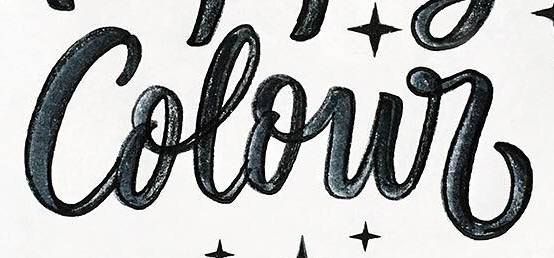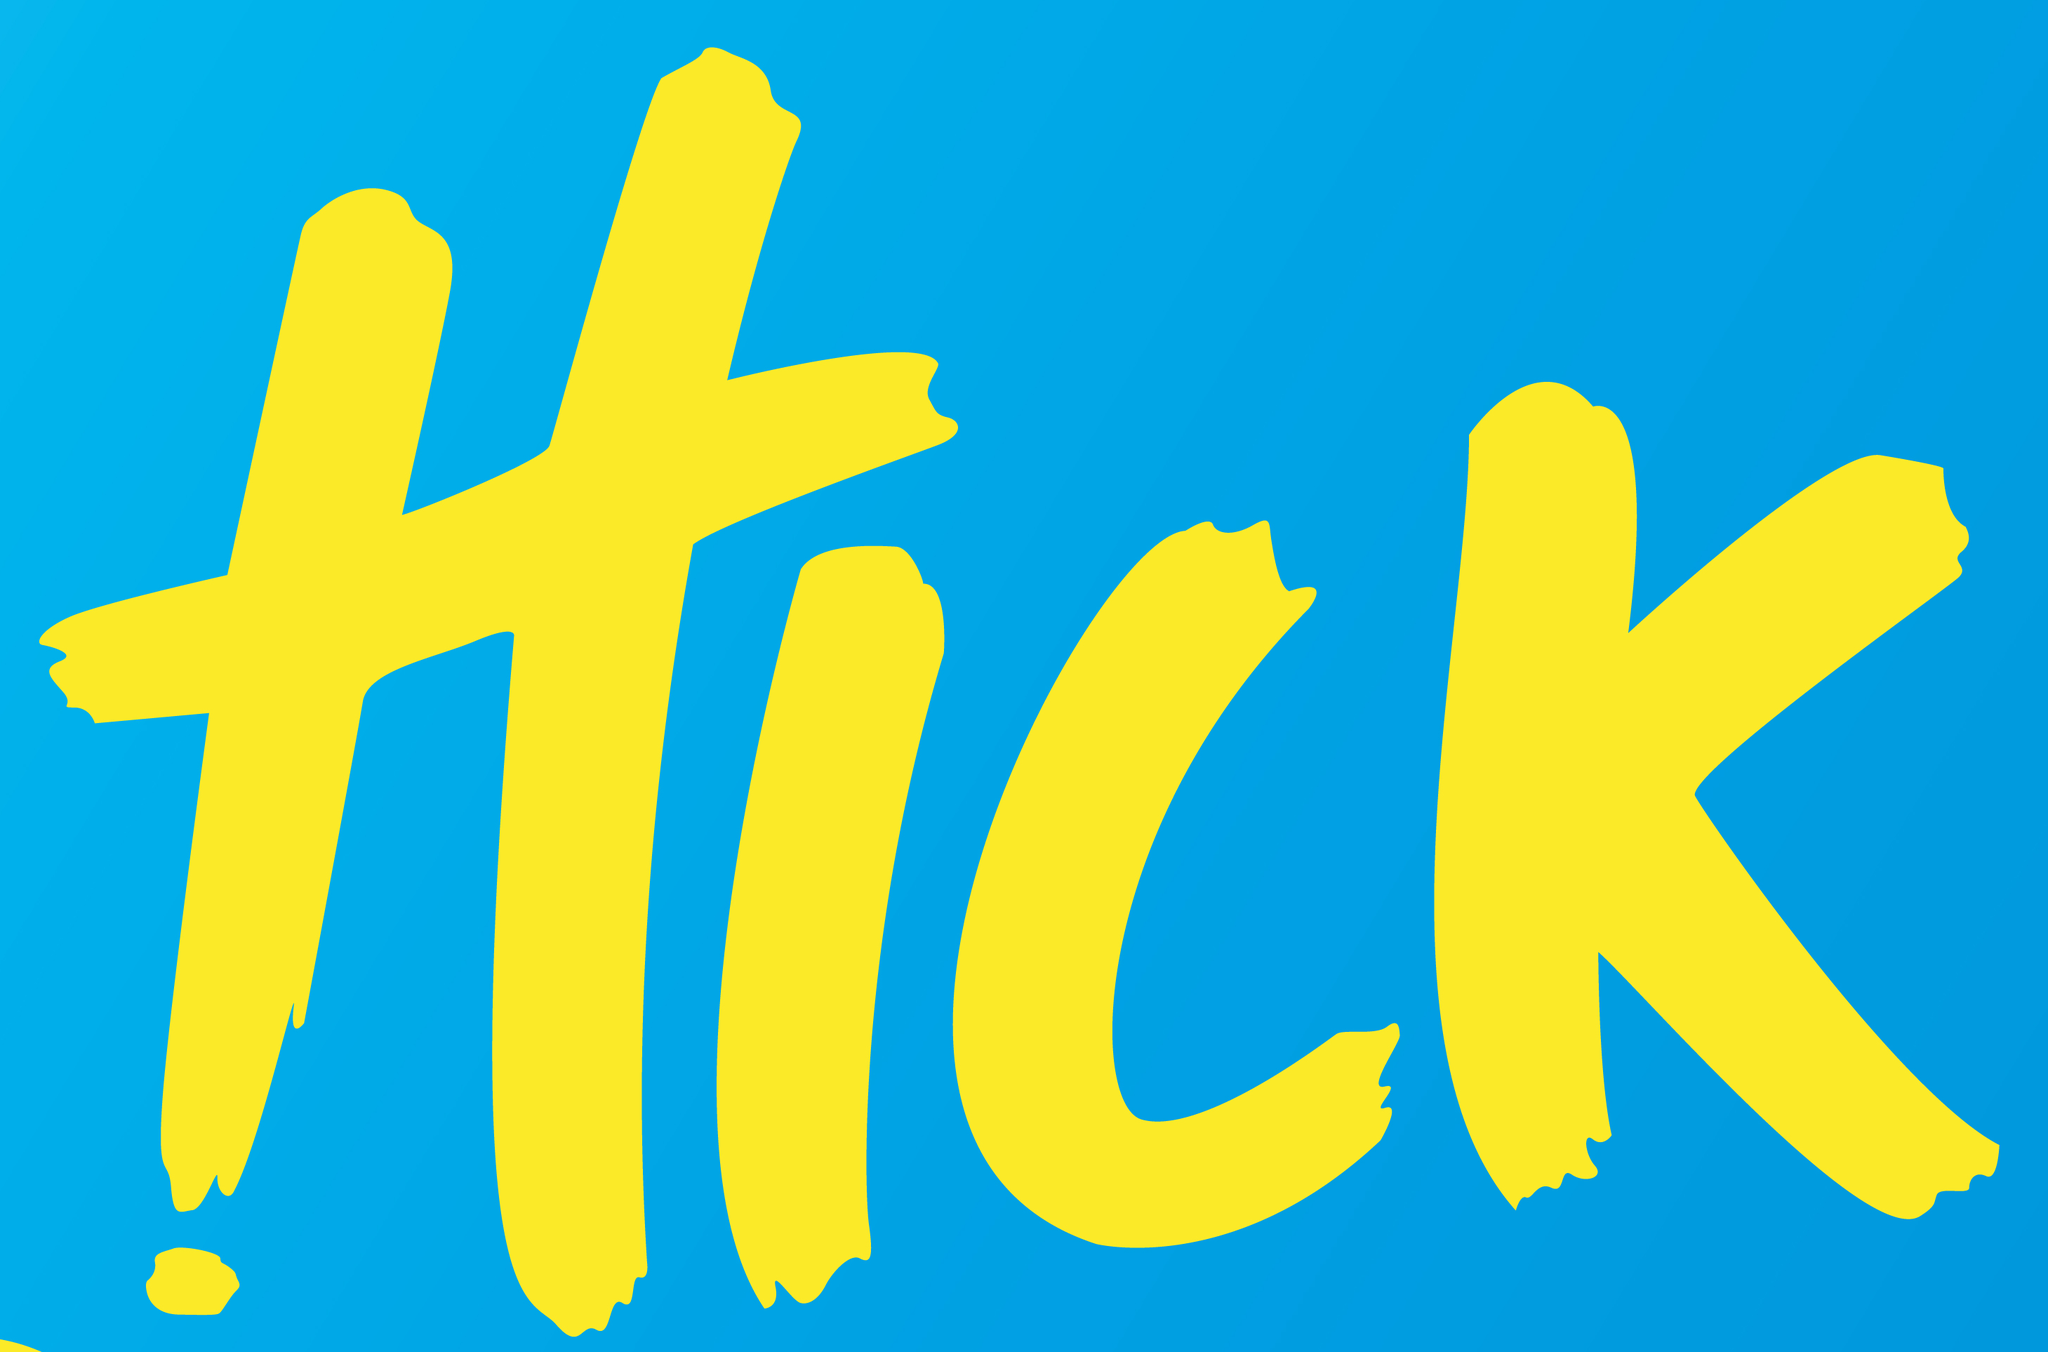Read the text from these images in sequence, separated by a semicolon. Colour; HICK 